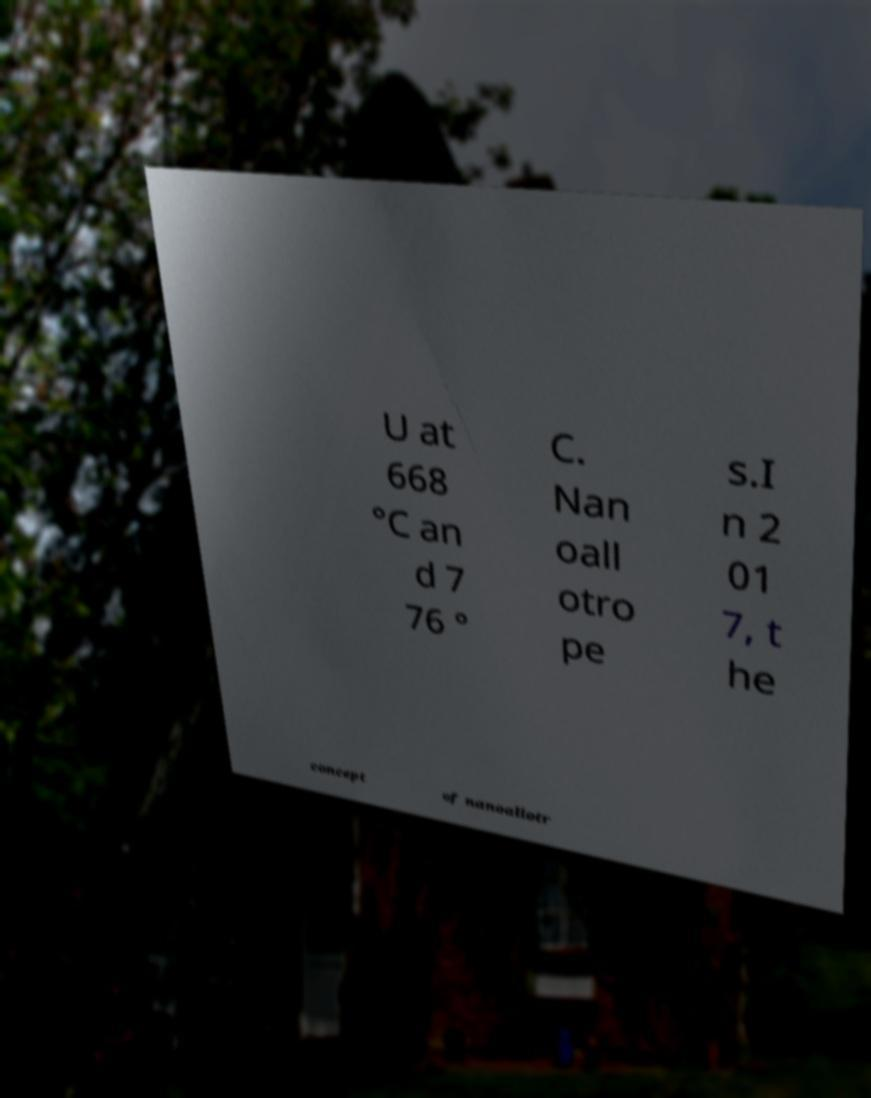Can you read and provide the text displayed in the image?This photo seems to have some interesting text. Can you extract and type it out for me? U at 668 °C an d 7 76 ° C. Nan oall otro pe s.I n 2 01 7, t he concept of nanoallotr 